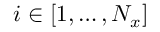<formula> <loc_0><loc_0><loc_500><loc_500>i \in [ 1 , \dots , N _ { x } ]</formula> 